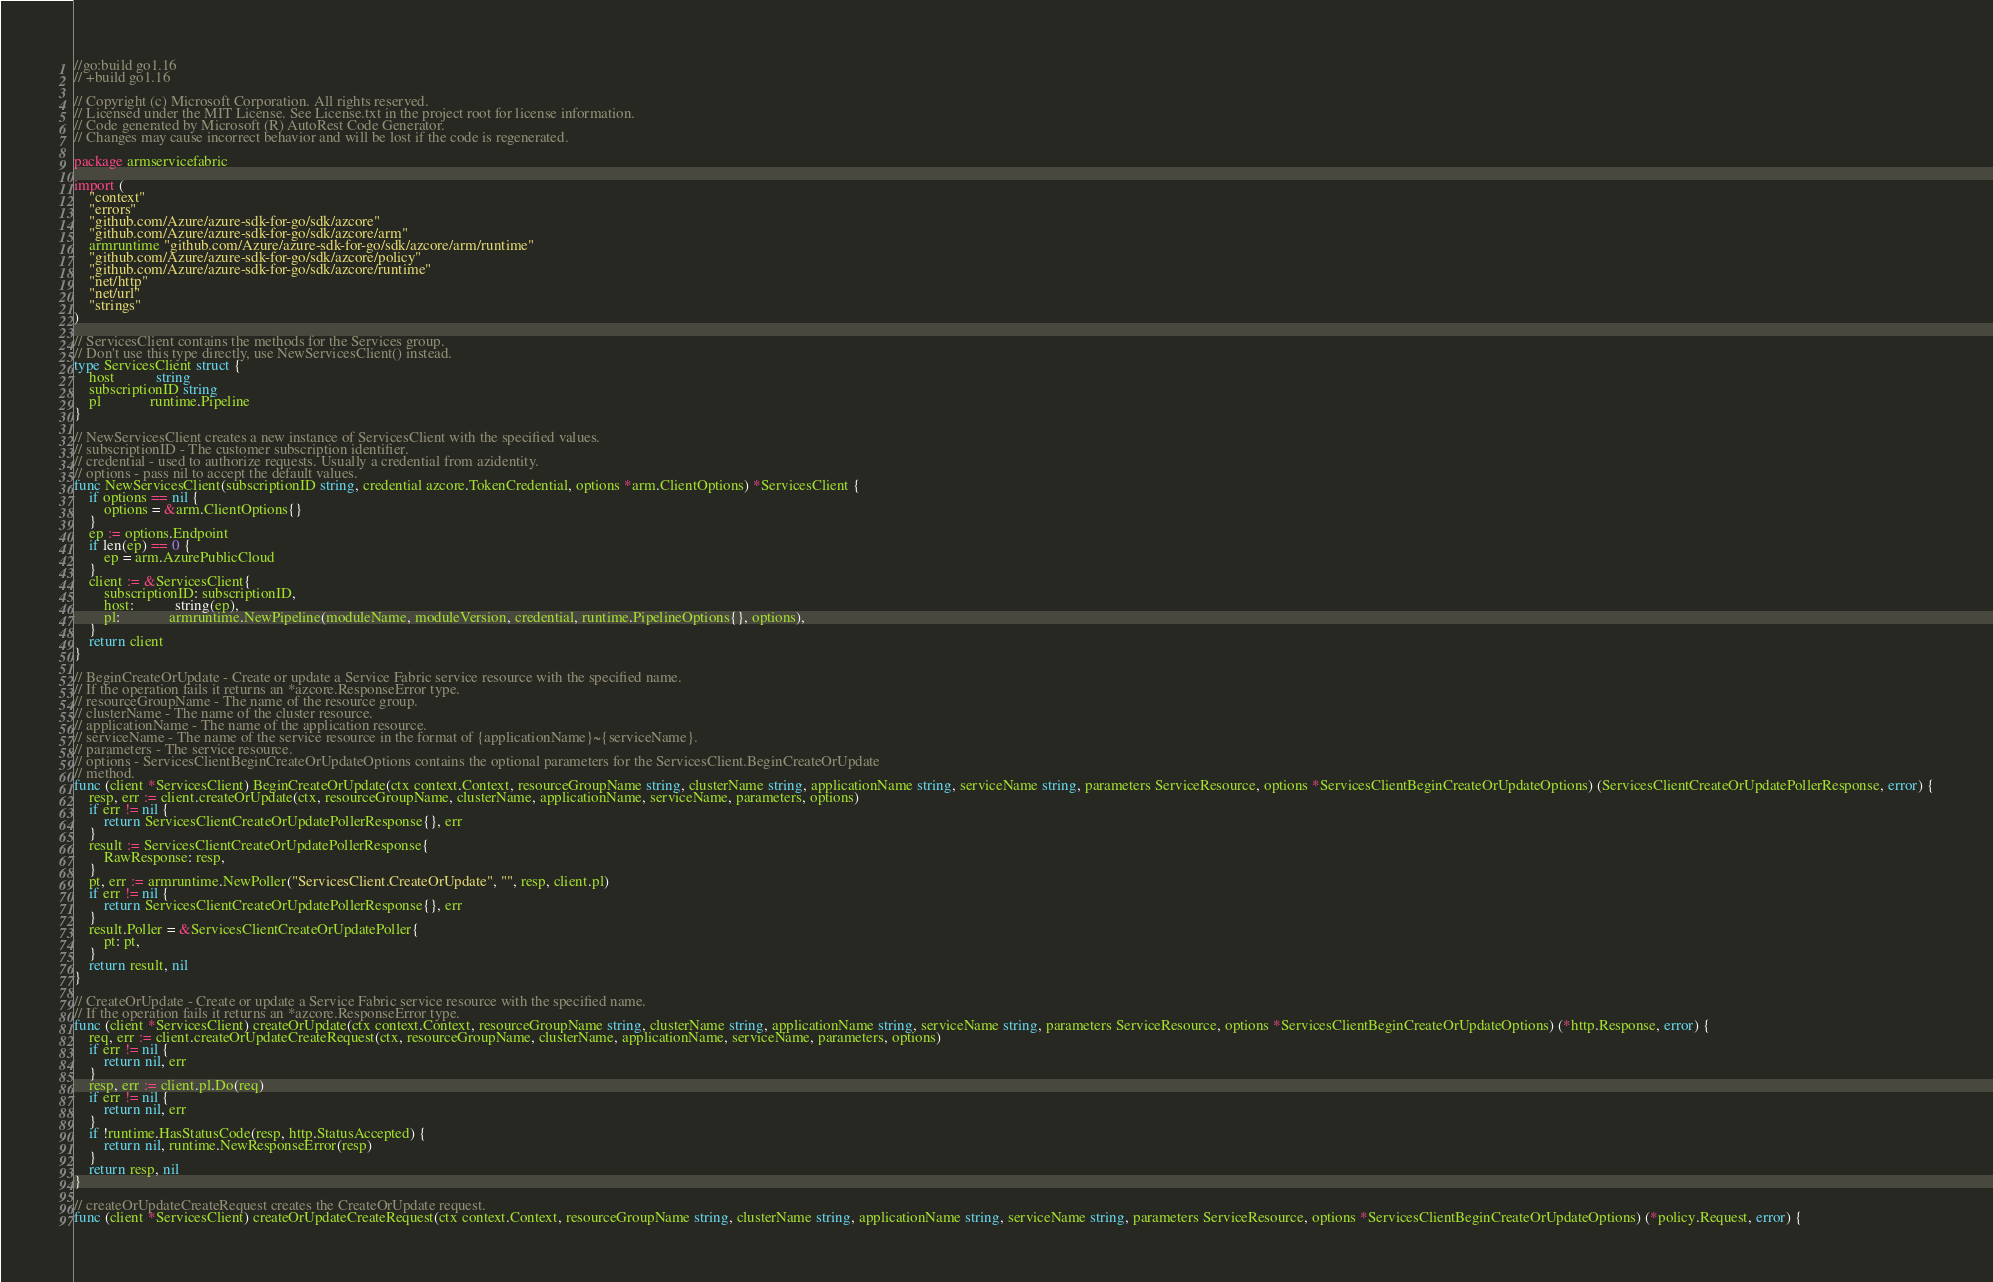Convert code to text. <code><loc_0><loc_0><loc_500><loc_500><_Go_>//go:build go1.16
// +build go1.16

// Copyright (c) Microsoft Corporation. All rights reserved.
// Licensed under the MIT License. See License.txt in the project root for license information.
// Code generated by Microsoft (R) AutoRest Code Generator.
// Changes may cause incorrect behavior and will be lost if the code is regenerated.

package armservicefabric

import (
	"context"
	"errors"
	"github.com/Azure/azure-sdk-for-go/sdk/azcore"
	"github.com/Azure/azure-sdk-for-go/sdk/azcore/arm"
	armruntime "github.com/Azure/azure-sdk-for-go/sdk/azcore/arm/runtime"
	"github.com/Azure/azure-sdk-for-go/sdk/azcore/policy"
	"github.com/Azure/azure-sdk-for-go/sdk/azcore/runtime"
	"net/http"
	"net/url"
	"strings"
)

// ServicesClient contains the methods for the Services group.
// Don't use this type directly, use NewServicesClient() instead.
type ServicesClient struct {
	host           string
	subscriptionID string
	pl             runtime.Pipeline
}

// NewServicesClient creates a new instance of ServicesClient with the specified values.
// subscriptionID - The customer subscription identifier.
// credential - used to authorize requests. Usually a credential from azidentity.
// options - pass nil to accept the default values.
func NewServicesClient(subscriptionID string, credential azcore.TokenCredential, options *arm.ClientOptions) *ServicesClient {
	if options == nil {
		options = &arm.ClientOptions{}
	}
	ep := options.Endpoint
	if len(ep) == 0 {
		ep = arm.AzurePublicCloud
	}
	client := &ServicesClient{
		subscriptionID: subscriptionID,
		host:           string(ep),
		pl:             armruntime.NewPipeline(moduleName, moduleVersion, credential, runtime.PipelineOptions{}, options),
	}
	return client
}

// BeginCreateOrUpdate - Create or update a Service Fabric service resource with the specified name.
// If the operation fails it returns an *azcore.ResponseError type.
// resourceGroupName - The name of the resource group.
// clusterName - The name of the cluster resource.
// applicationName - The name of the application resource.
// serviceName - The name of the service resource in the format of {applicationName}~{serviceName}.
// parameters - The service resource.
// options - ServicesClientBeginCreateOrUpdateOptions contains the optional parameters for the ServicesClient.BeginCreateOrUpdate
// method.
func (client *ServicesClient) BeginCreateOrUpdate(ctx context.Context, resourceGroupName string, clusterName string, applicationName string, serviceName string, parameters ServiceResource, options *ServicesClientBeginCreateOrUpdateOptions) (ServicesClientCreateOrUpdatePollerResponse, error) {
	resp, err := client.createOrUpdate(ctx, resourceGroupName, clusterName, applicationName, serviceName, parameters, options)
	if err != nil {
		return ServicesClientCreateOrUpdatePollerResponse{}, err
	}
	result := ServicesClientCreateOrUpdatePollerResponse{
		RawResponse: resp,
	}
	pt, err := armruntime.NewPoller("ServicesClient.CreateOrUpdate", "", resp, client.pl)
	if err != nil {
		return ServicesClientCreateOrUpdatePollerResponse{}, err
	}
	result.Poller = &ServicesClientCreateOrUpdatePoller{
		pt: pt,
	}
	return result, nil
}

// CreateOrUpdate - Create or update a Service Fabric service resource with the specified name.
// If the operation fails it returns an *azcore.ResponseError type.
func (client *ServicesClient) createOrUpdate(ctx context.Context, resourceGroupName string, clusterName string, applicationName string, serviceName string, parameters ServiceResource, options *ServicesClientBeginCreateOrUpdateOptions) (*http.Response, error) {
	req, err := client.createOrUpdateCreateRequest(ctx, resourceGroupName, clusterName, applicationName, serviceName, parameters, options)
	if err != nil {
		return nil, err
	}
	resp, err := client.pl.Do(req)
	if err != nil {
		return nil, err
	}
	if !runtime.HasStatusCode(resp, http.StatusAccepted) {
		return nil, runtime.NewResponseError(resp)
	}
	return resp, nil
}

// createOrUpdateCreateRequest creates the CreateOrUpdate request.
func (client *ServicesClient) createOrUpdateCreateRequest(ctx context.Context, resourceGroupName string, clusterName string, applicationName string, serviceName string, parameters ServiceResource, options *ServicesClientBeginCreateOrUpdateOptions) (*policy.Request, error) {</code> 